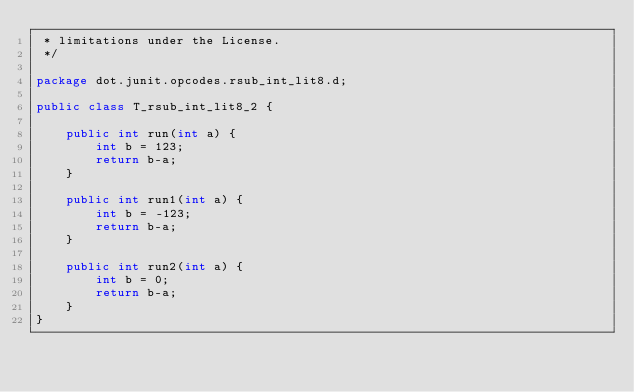Convert code to text. <code><loc_0><loc_0><loc_500><loc_500><_Java_> * limitations under the License.
 */

package dot.junit.opcodes.rsub_int_lit8.d;

public class T_rsub_int_lit8_2 {
    
    public int run(int a) {
        int b = 123;
        return b-a;
    }
    
    public int run1(int a) {
        int b = -123;
        return b-a;
    }
    
    public int run2(int a) {
        int b = 0;
        return b-a;
    }
}
</code> 